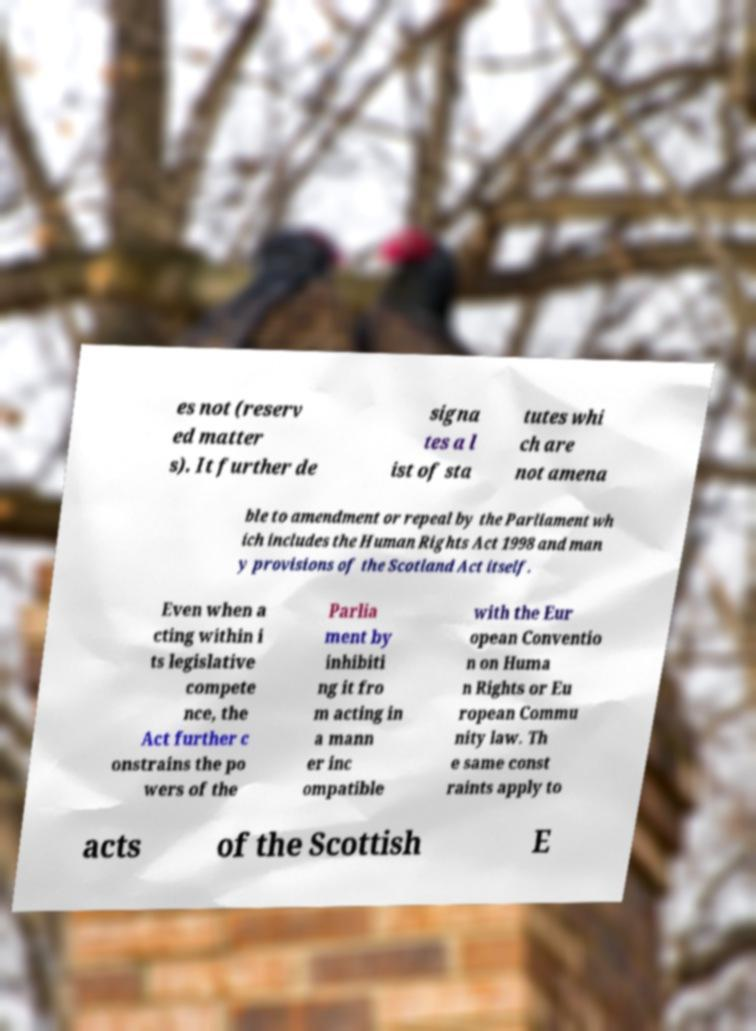Could you extract and type out the text from this image? es not (reserv ed matter s). It further de signa tes a l ist of sta tutes whi ch are not amena ble to amendment or repeal by the Parliament wh ich includes the Human Rights Act 1998 and man y provisions of the Scotland Act itself. Even when a cting within i ts legislative compete nce, the Act further c onstrains the po wers of the Parlia ment by inhibiti ng it fro m acting in a mann er inc ompatible with the Eur opean Conventio n on Huma n Rights or Eu ropean Commu nity law. Th e same const raints apply to acts of the Scottish E 